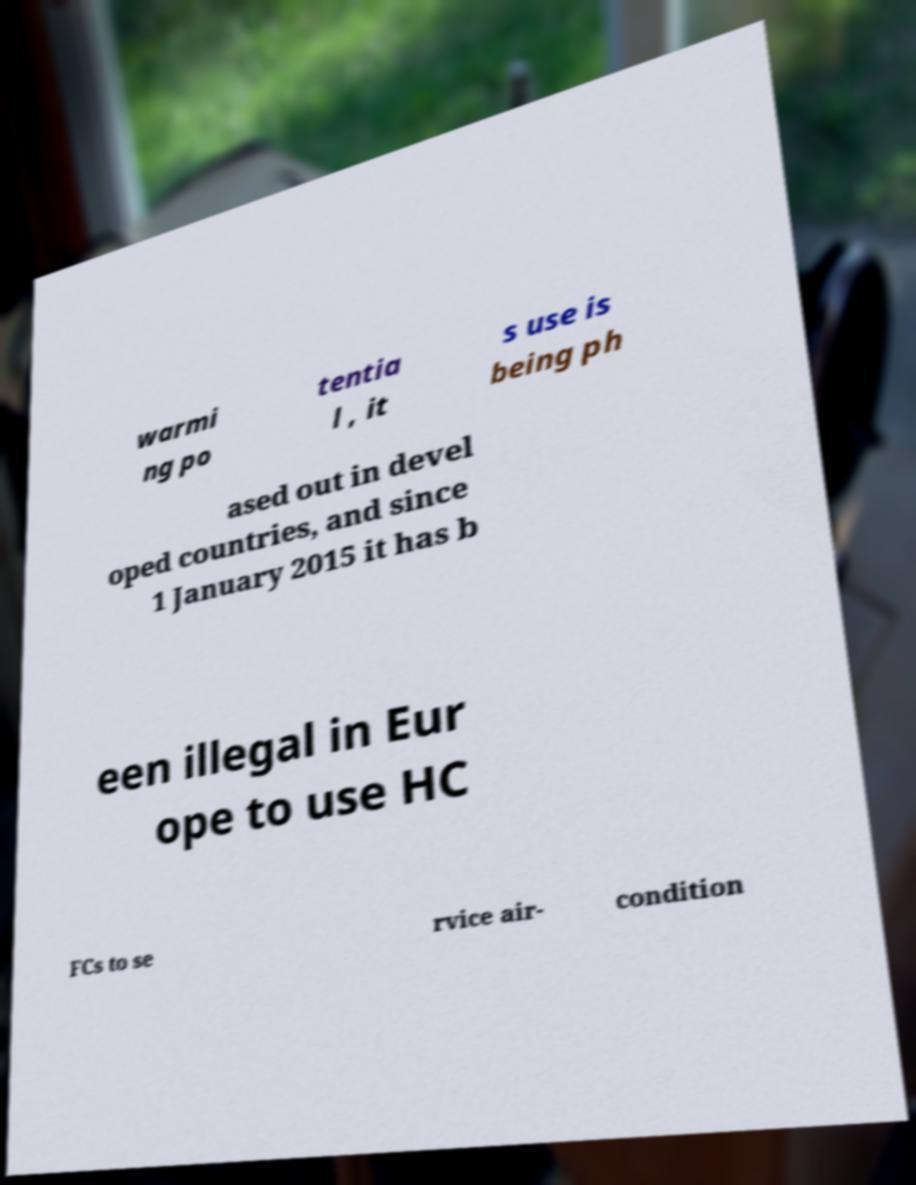Could you extract and type out the text from this image? warmi ng po tentia l , it s use is being ph ased out in devel oped countries, and since 1 January 2015 it has b een illegal in Eur ope to use HC FCs to se rvice air- condition 